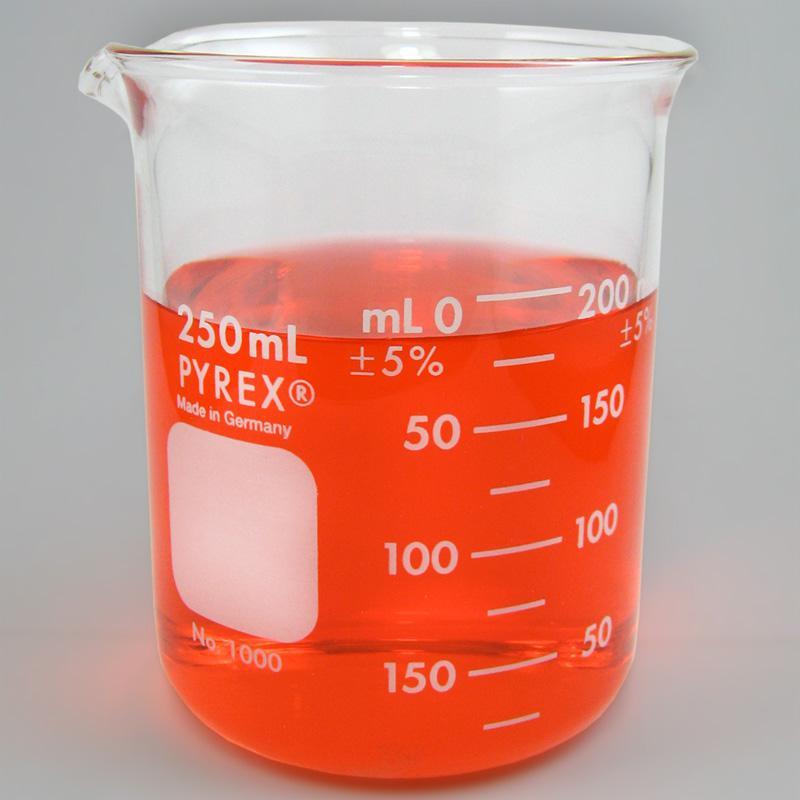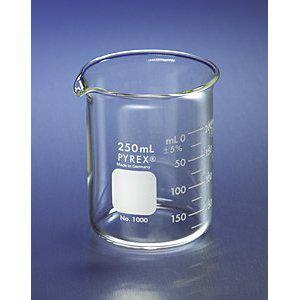The first image is the image on the left, the second image is the image on the right. Examine the images to the left and right. Is the description "there is red liquid in a glass beaker" accurate? Answer yes or no. Yes. The first image is the image on the left, the second image is the image on the right. For the images shown, is this caption "There is no less than one clear beaker with red liquid in it" true? Answer yes or no. Yes. 